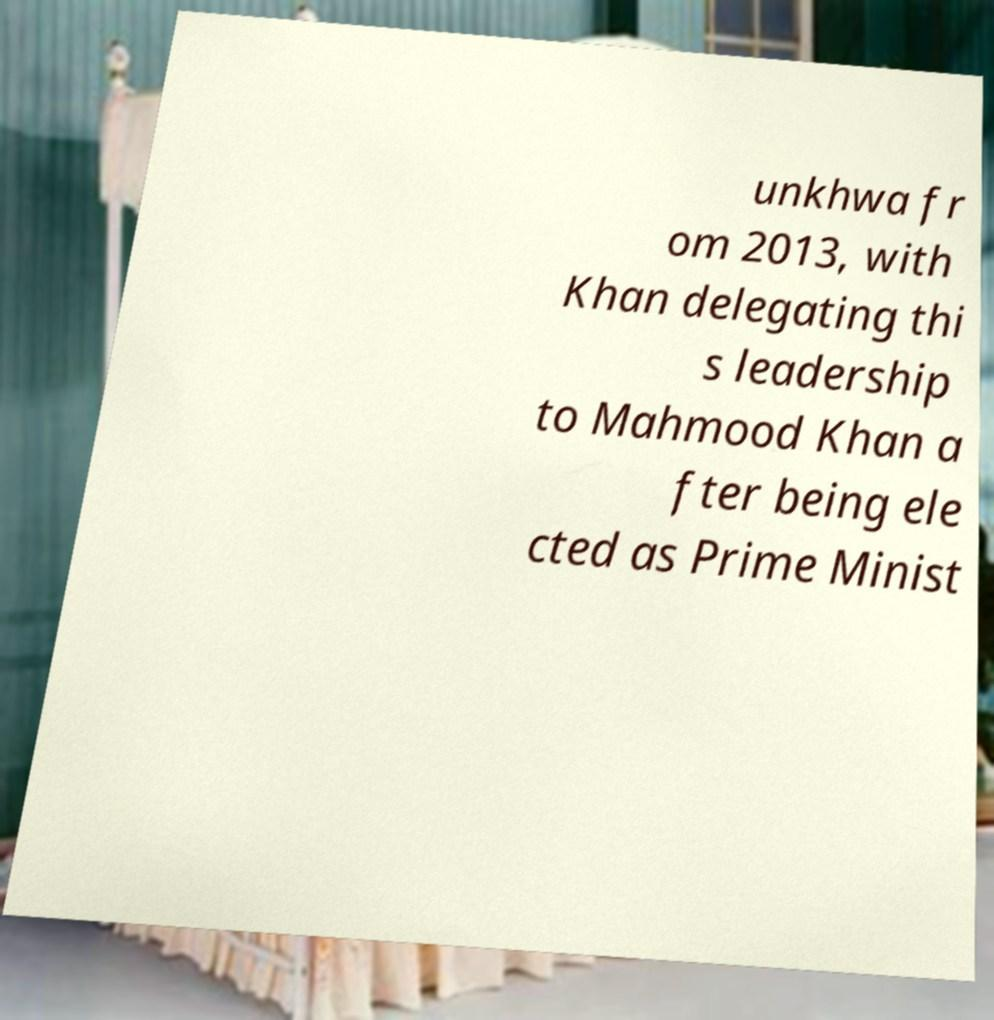Could you extract and type out the text from this image? unkhwa fr om 2013, with Khan delegating thi s leadership to Mahmood Khan a fter being ele cted as Prime Minist 